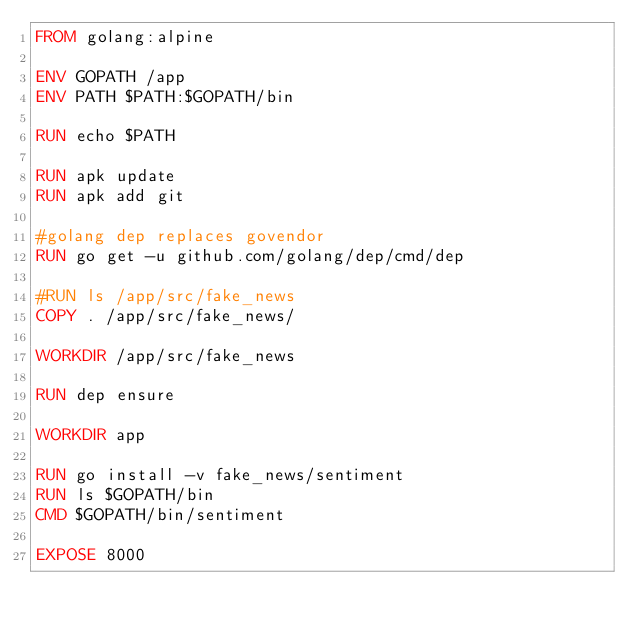<code> <loc_0><loc_0><loc_500><loc_500><_Dockerfile_>FROM golang:alpine

ENV GOPATH /app
ENV PATH $PATH:$GOPATH/bin

RUN echo $PATH

RUN apk update
RUN apk add git

#golang dep replaces govendor
RUN go get -u github.com/golang/dep/cmd/dep

#RUN ls /app/src/fake_news
COPY . /app/src/fake_news/

WORKDIR /app/src/fake_news

RUN dep ensure

WORKDIR app

RUN go install -v fake_news/sentiment
RUN ls $GOPATH/bin
CMD $GOPATH/bin/sentiment

EXPOSE 8000</code> 